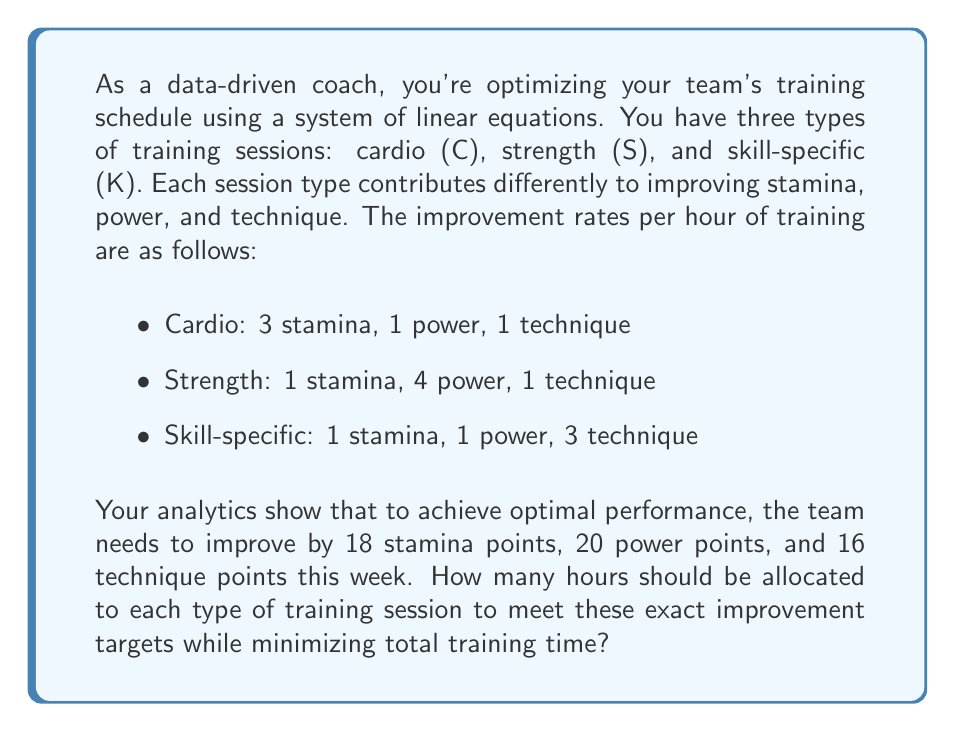Help me with this question. Let's approach this problem systematically using a system of linear equations:

1) Let $x$, $y$, and $z$ represent the hours spent on cardio, strength, and skill-specific training respectively.

2) Based on the given information, we can set up the following system of equations:

   $$\begin{cases}
   3x + y + z = 18 \text{ (Stamina)}\\
   x + 4y + z = 20 \text{ (Power)}\\
   x + y + 3z = 16 \text{ (Technique)}
   \end{cases}$$

3) To solve this system, we'll use the elimination method:
   
   a) Subtract the first equation from the second:
      $$3y = 2$$
      $$y = \frac{2}{3}$$

   b) Subtract the first equation from the third:
      $$2z = -2$$
      $$z = -1$$

   c) Substitute these values into the first equation:
      $$3x + \frac{2}{3} + (-1) = 18$$
      $$3x = 18 + \frac{1}{3}$$
      $$x = 6 + \frac{1}{9} = \frac{55}{9}$$

4) Now we have our solution: 
   $x = \frac{55}{9}$, $y = \frac{2}{3}$, $z = -1$

5) However, we can't have negative training hours, so this solution is not feasible in reality. This means there's no way to achieve the exact improvement targets while minimizing total training time.

6) In practice, we would need to adjust our targets or constraints. For example, we could allow for exceeding the targets slightly or increase the minimum training time.
Answer: There is no feasible solution that meets the exact improvement targets while minimizing total training time. The mathematical solution ($\frac{55}{9}$ hours of cardio, $\frac{2}{3}$ hours of strength, and -1 hours of skill-specific training) includes negative training time, which is impossible in reality. 